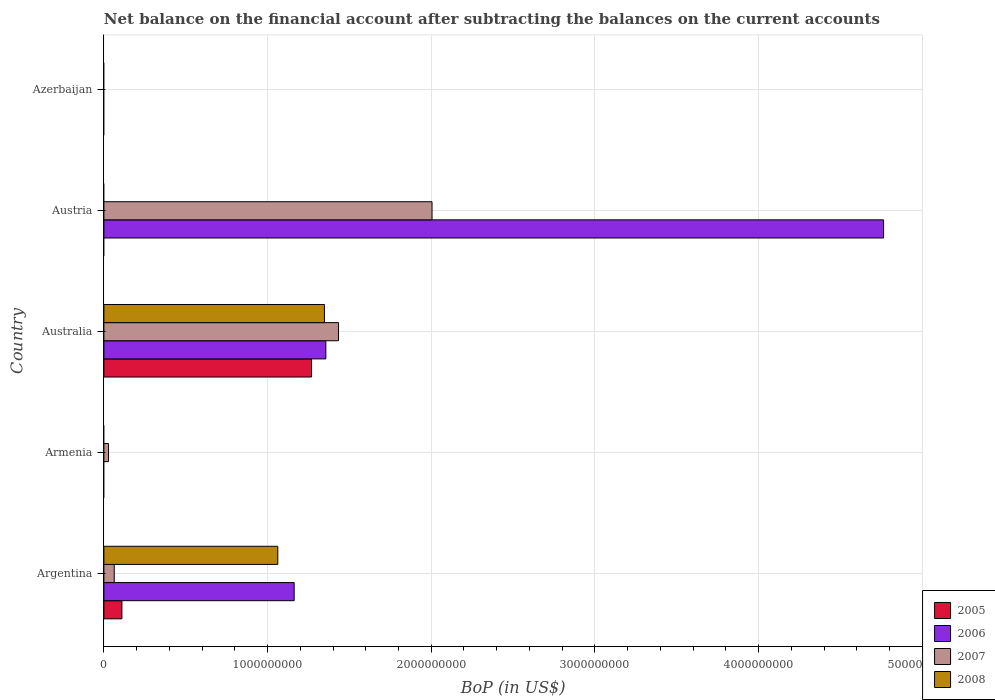Are the number of bars on each tick of the Y-axis equal?
Keep it short and to the point. No. What is the label of the 1st group of bars from the top?
Provide a short and direct response. Azerbaijan. What is the Balance of Payments in 2008 in Armenia?
Ensure brevity in your answer.  0. Across all countries, what is the maximum Balance of Payments in 2007?
Your answer should be very brief. 2.00e+09. Across all countries, what is the minimum Balance of Payments in 2005?
Ensure brevity in your answer.  0. In which country was the Balance of Payments in 2005 maximum?
Make the answer very short. Australia. What is the total Balance of Payments in 2007 in the graph?
Your answer should be compact. 3.53e+09. What is the difference between the Balance of Payments in 2005 in Argentina and that in Australia?
Your response must be concise. -1.16e+09. What is the difference between the Balance of Payments in 2006 in Austria and the Balance of Payments in 2008 in Australia?
Provide a short and direct response. 3.42e+09. What is the average Balance of Payments in 2007 per country?
Your response must be concise. 7.06e+08. What is the difference between the Balance of Payments in 2008 and Balance of Payments in 2007 in Argentina?
Give a very brief answer. 9.99e+08. In how many countries, is the Balance of Payments in 2008 greater than 1000000000 US$?
Provide a succinct answer. 2. What is the ratio of the Balance of Payments in 2007 in Argentina to that in Australia?
Make the answer very short. 0.04. Is the difference between the Balance of Payments in 2008 in Argentina and Australia greater than the difference between the Balance of Payments in 2007 in Argentina and Australia?
Your response must be concise. Yes. What is the difference between the highest and the second highest Balance of Payments in 2007?
Provide a succinct answer. 5.72e+08. What is the difference between the highest and the lowest Balance of Payments in 2008?
Give a very brief answer. 1.35e+09. Is the sum of the Balance of Payments in 2007 in Argentina and Australia greater than the maximum Balance of Payments in 2008 across all countries?
Your answer should be very brief. Yes. Is it the case that in every country, the sum of the Balance of Payments in 2007 and Balance of Payments in 2005 is greater than the sum of Balance of Payments in 2006 and Balance of Payments in 2008?
Offer a terse response. No. Is it the case that in every country, the sum of the Balance of Payments in 2008 and Balance of Payments in 2006 is greater than the Balance of Payments in 2007?
Keep it short and to the point. No. Are all the bars in the graph horizontal?
Ensure brevity in your answer.  Yes. Are the values on the major ticks of X-axis written in scientific E-notation?
Keep it short and to the point. No. Does the graph contain any zero values?
Give a very brief answer. Yes. Where does the legend appear in the graph?
Provide a short and direct response. Bottom right. How are the legend labels stacked?
Make the answer very short. Vertical. What is the title of the graph?
Your answer should be very brief. Net balance on the financial account after subtracting the balances on the current accounts. Does "2012" appear as one of the legend labels in the graph?
Offer a terse response. No. What is the label or title of the X-axis?
Your answer should be compact. BoP (in US$). What is the label or title of the Y-axis?
Provide a succinct answer. Country. What is the BoP (in US$) of 2005 in Argentina?
Offer a terse response. 1.10e+08. What is the BoP (in US$) of 2006 in Argentina?
Your answer should be very brief. 1.16e+09. What is the BoP (in US$) in 2007 in Argentina?
Your answer should be very brief. 6.32e+07. What is the BoP (in US$) of 2008 in Argentina?
Give a very brief answer. 1.06e+09. What is the BoP (in US$) of 2005 in Armenia?
Provide a succinct answer. 0. What is the BoP (in US$) in 2006 in Armenia?
Keep it short and to the point. 0. What is the BoP (in US$) in 2007 in Armenia?
Offer a terse response. 2.83e+07. What is the BoP (in US$) of 2005 in Australia?
Your response must be concise. 1.27e+09. What is the BoP (in US$) of 2006 in Australia?
Provide a short and direct response. 1.36e+09. What is the BoP (in US$) in 2007 in Australia?
Keep it short and to the point. 1.43e+09. What is the BoP (in US$) of 2008 in Australia?
Offer a very short reply. 1.35e+09. What is the BoP (in US$) of 2005 in Austria?
Provide a short and direct response. 0. What is the BoP (in US$) in 2006 in Austria?
Ensure brevity in your answer.  4.76e+09. What is the BoP (in US$) in 2007 in Austria?
Your answer should be very brief. 2.00e+09. What is the BoP (in US$) of 2008 in Austria?
Make the answer very short. 0. What is the BoP (in US$) of 2005 in Azerbaijan?
Ensure brevity in your answer.  0. What is the BoP (in US$) in 2007 in Azerbaijan?
Your answer should be very brief. 0. Across all countries, what is the maximum BoP (in US$) of 2005?
Ensure brevity in your answer.  1.27e+09. Across all countries, what is the maximum BoP (in US$) in 2006?
Keep it short and to the point. 4.76e+09. Across all countries, what is the maximum BoP (in US$) of 2007?
Make the answer very short. 2.00e+09. Across all countries, what is the maximum BoP (in US$) of 2008?
Your answer should be compact. 1.35e+09. Across all countries, what is the minimum BoP (in US$) in 2005?
Ensure brevity in your answer.  0. What is the total BoP (in US$) in 2005 in the graph?
Your answer should be very brief. 1.38e+09. What is the total BoP (in US$) in 2006 in the graph?
Your response must be concise. 7.28e+09. What is the total BoP (in US$) in 2007 in the graph?
Offer a very short reply. 3.53e+09. What is the total BoP (in US$) of 2008 in the graph?
Provide a succinct answer. 2.41e+09. What is the difference between the BoP (in US$) in 2007 in Argentina and that in Armenia?
Your response must be concise. 3.49e+07. What is the difference between the BoP (in US$) in 2005 in Argentina and that in Australia?
Your answer should be compact. -1.16e+09. What is the difference between the BoP (in US$) in 2006 in Argentina and that in Australia?
Provide a succinct answer. -1.94e+08. What is the difference between the BoP (in US$) of 2007 in Argentina and that in Australia?
Your answer should be compact. -1.37e+09. What is the difference between the BoP (in US$) of 2008 in Argentina and that in Australia?
Your answer should be compact. -2.85e+08. What is the difference between the BoP (in US$) of 2006 in Argentina and that in Austria?
Ensure brevity in your answer.  -3.60e+09. What is the difference between the BoP (in US$) of 2007 in Argentina and that in Austria?
Give a very brief answer. -1.94e+09. What is the difference between the BoP (in US$) of 2007 in Armenia and that in Australia?
Ensure brevity in your answer.  -1.41e+09. What is the difference between the BoP (in US$) of 2007 in Armenia and that in Austria?
Ensure brevity in your answer.  -1.98e+09. What is the difference between the BoP (in US$) of 2006 in Australia and that in Austria?
Your response must be concise. -3.41e+09. What is the difference between the BoP (in US$) of 2007 in Australia and that in Austria?
Your answer should be compact. -5.72e+08. What is the difference between the BoP (in US$) in 2005 in Argentina and the BoP (in US$) in 2007 in Armenia?
Your answer should be compact. 8.18e+07. What is the difference between the BoP (in US$) in 2006 in Argentina and the BoP (in US$) in 2007 in Armenia?
Your response must be concise. 1.13e+09. What is the difference between the BoP (in US$) of 2005 in Argentina and the BoP (in US$) of 2006 in Australia?
Provide a short and direct response. -1.25e+09. What is the difference between the BoP (in US$) of 2005 in Argentina and the BoP (in US$) of 2007 in Australia?
Your answer should be very brief. -1.32e+09. What is the difference between the BoP (in US$) in 2005 in Argentina and the BoP (in US$) in 2008 in Australia?
Your answer should be compact. -1.24e+09. What is the difference between the BoP (in US$) in 2006 in Argentina and the BoP (in US$) in 2007 in Australia?
Make the answer very short. -2.71e+08. What is the difference between the BoP (in US$) in 2006 in Argentina and the BoP (in US$) in 2008 in Australia?
Make the answer very short. -1.85e+08. What is the difference between the BoP (in US$) in 2007 in Argentina and the BoP (in US$) in 2008 in Australia?
Your response must be concise. -1.28e+09. What is the difference between the BoP (in US$) of 2005 in Argentina and the BoP (in US$) of 2006 in Austria?
Offer a terse response. -4.65e+09. What is the difference between the BoP (in US$) in 2005 in Argentina and the BoP (in US$) in 2007 in Austria?
Keep it short and to the point. -1.89e+09. What is the difference between the BoP (in US$) in 2006 in Argentina and the BoP (in US$) in 2007 in Austria?
Make the answer very short. -8.42e+08. What is the difference between the BoP (in US$) of 2007 in Armenia and the BoP (in US$) of 2008 in Australia?
Your answer should be compact. -1.32e+09. What is the difference between the BoP (in US$) of 2005 in Australia and the BoP (in US$) of 2006 in Austria?
Provide a succinct answer. -3.50e+09. What is the difference between the BoP (in US$) of 2005 in Australia and the BoP (in US$) of 2007 in Austria?
Your answer should be very brief. -7.36e+08. What is the difference between the BoP (in US$) of 2006 in Australia and the BoP (in US$) of 2007 in Austria?
Give a very brief answer. -6.49e+08. What is the average BoP (in US$) in 2005 per country?
Offer a terse response. 2.76e+08. What is the average BoP (in US$) in 2006 per country?
Keep it short and to the point. 1.46e+09. What is the average BoP (in US$) in 2007 per country?
Your answer should be very brief. 7.06e+08. What is the average BoP (in US$) of 2008 per country?
Give a very brief answer. 4.82e+08. What is the difference between the BoP (in US$) in 2005 and BoP (in US$) in 2006 in Argentina?
Give a very brief answer. -1.05e+09. What is the difference between the BoP (in US$) of 2005 and BoP (in US$) of 2007 in Argentina?
Offer a terse response. 4.69e+07. What is the difference between the BoP (in US$) in 2005 and BoP (in US$) in 2008 in Argentina?
Ensure brevity in your answer.  -9.53e+08. What is the difference between the BoP (in US$) of 2006 and BoP (in US$) of 2007 in Argentina?
Provide a succinct answer. 1.10e+09. What is the difference between the BoP (in US$) of 2006 and BoP (in US$) of 2008 in Argentina?
Your response must be concise. 1.00e+08. What is the difference between the BoP (in US$) in 2007 and BoP (in US$) in 2008 in Argentina?
Provide a short and direct response. -9.99e+08. What is the difference between the BoP (in US$) of 2005 and BoP (in US$) of 2006 in Australia?
Keep it short and to the point. -8.74e+07. What is the difference between the BoP (in US$) in 2005 and BoP (in US$) in 2007 in Australia?
Your answer should be compact. -1.65e+08. What is the difference between the BoP (in US$) of 2005 and BoP (in US$) of 2008 in Australia?
Your response must be concise. -7.86e+07. What is the difference between the BoP (in US$) of 2006 and BoP (in US$) of 2007 in Australia?
Offer a terse response. -7.72e+07. What is the difference between the BoP (in US$) in 2006 and BoP (in US$) in 2008 in Australia?
Your answer should be compact. 8.75e+06. What is the difference between the BoP (in US$) in 2007 and BoP (in US$) in 2008 in Australia?
Provide a short and direct response. 8.59e+07. What is the difference between the BoP (in US$) in 2006 and BoP (in US$) in 2007 in Austria?
Provide a succinct answer. 2.76e+09. What is the ratio of the BoP (in US$) in 2007 in Argentina to that in Armenia?
Your answer should be compact. 2.23. What is the ratio of the BoP (in US$) in 2005 in Argentina to that in Australia?
Make the answer very short. 0.09. What is the ratio of the BoP (in US$) of 2006 in Argentina to that in Australia?
Make the answer very short. 0.86. What is the ratio of the BoP (in US$) in 2007 in Argentina to that in Australia?
Give a very brief answer. 0.04. What is the ratio of the BoP (in US$) in 2008 in Argentina to that in Australia?
Give a very brief answer. 0.79. What is the ratio of the BoP (in US$) in 2006 in Argentina to that in Austria?
Offer a very short reply. 0.24. What is the ratio of the BoP (in US$) in 2007 in Argentina to that in Austria?
Keep it short and to the point. 0.03. What is the ratio of the BoP (in US$) in 2007 in Armenia to that in Australia?
Your response must be concise. 0.02. What is the ratio of the BoP (in US$) in 2007 in Armenia to that in Austria?
Provide a succinct answer. 0.01. What is the ratio of the BoP (in US$) in 2006 in Australia to that in Austria?
Offer a very short reply. 0.28. What is the ratio of the BoP (in US$) of 2007 in Australia to that in Austria?
Provide a short and direct response. 0.71. What is the difference between the highest and the second highest BoP (in US$) in 2006?
Your answer should be very brief. 3.41e+09. What is the difference between the highest and the second highest BoP (in US$) of 2007?
Keep it short and to the point. 5.72e+08. What is the difference between the highest and the lowest BoP (in US$) in 2005?
Make the answer very short. 1.27e+09. What is the difference between the highest and the lowest BoP (in US$) in 2006?
Offer a very short reply. 4.76e+09. What is the difference between the highest and the lowest BoP (in US$) in 2007?
Your answer should be compact. 2.00e+09. What is the difference between the highest and the lowest BoP (in US$) of 2008?
Keep it short and to the point. 1.35e+09. 